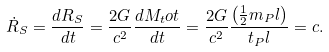<formula> <loc_0><loc_0><loc_500><loc_500>\dot { R } _ { S } = \frac { d R _ { S } } { d t } = \frac { 2 G } { c ^ { 2 } } \frac { d M _ { t } o t } { d t } = \frac { 2 G } { c ^ { 2 } } \frac { { \left ( { \frac { 1 } { 2 } m _ { P } l } \right ) } } { t _ { P } l } = c .</formula> 